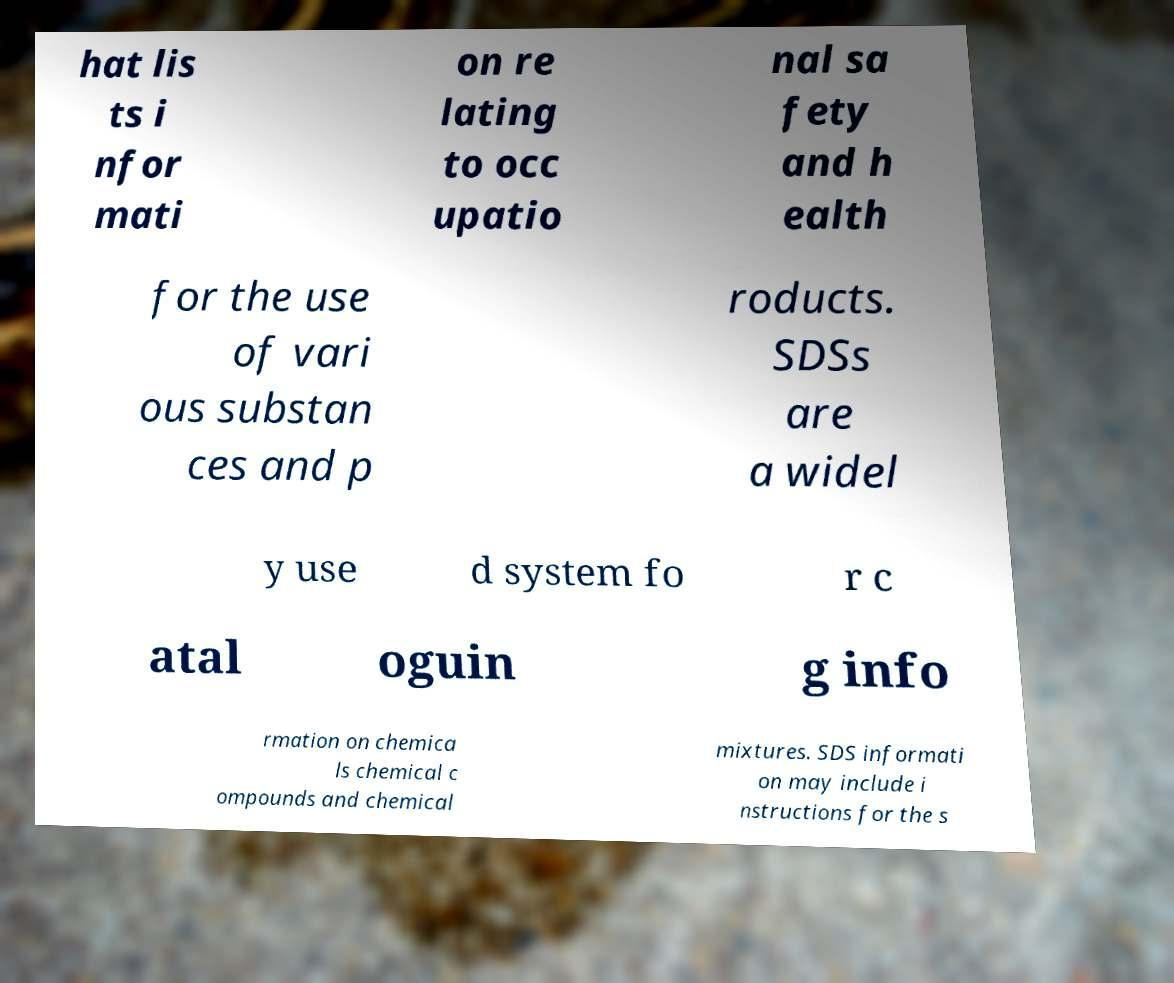Could you extract and type out the text from this image? hat lis ts i nfor mati on re lating to occ upatio nal sa fety and h ealth for the use of vari ous substan ces and p roducts. SDSs are a widel y use d system fo r c atal oguin g info rmation on chemica ls chemical c ompounds and chemical mixtures. SDS informati on may include i nstructions for the s 